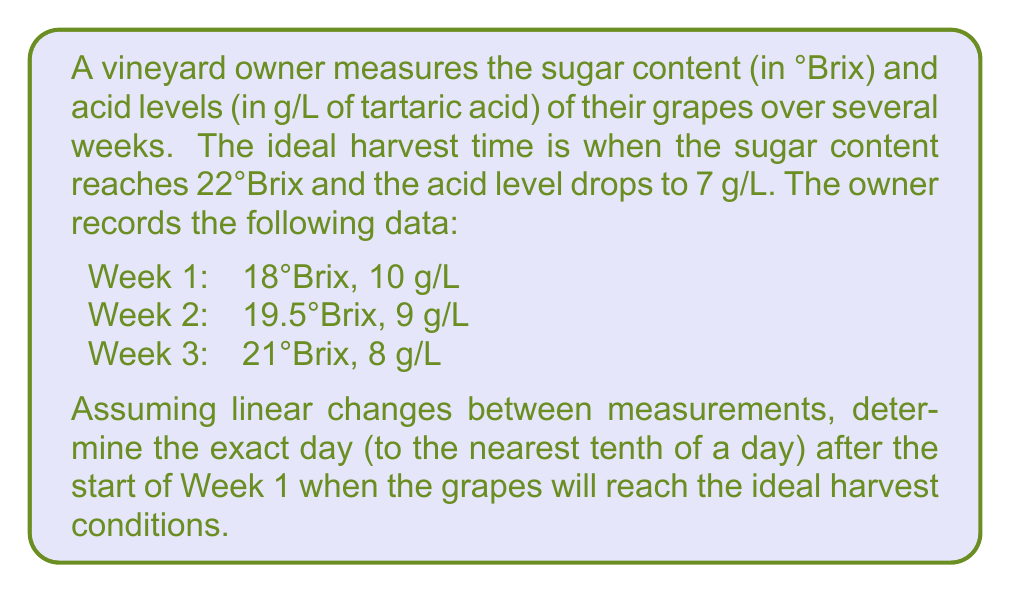Give your solution to this math problem. To solve this problem, we need to calculate the rates of change for both sugar content and acid levels, then determine when they will reach the ideal values.

1. Calculate the rate of change for sugar content:
   $$\text{Sugar rate} = \frac{21 - 18}{14 \text{ days}} = \frac{3}{14} = 0.2143 \text{ °Brix/day}$$

2. Calculate the rate of change for acid levels:
   $$\text{Acid rate} = \frac{8 - 10}{14 \text{ days}} = -\frac{1}{7} = -0.1429 \text{ g/L/day}$$

3. Calculate the time needed to reach 22°Brix from Week 3:
   $$t_{\text{sugar}} = \frac{22 - 21}{0.2143} = 4.67 \text{ days}$$

4. Calculate the time needed to reach 7 g/L acid from Week 3:
   $$t_{\text{acid}} = \frac{7 - 8}{-0.1429} = 7 \text{ days}$$

5. The ideal harvest time will be when both conditions are met, which is the later of the two times. In this case, it's 7 days after Week 3.

6. Calculate the total number of days from the start of Week 1:
   $$\text{Total days} = 14 \text{ (2 weeks)} + 7 = 21 \text{ days}$$

Therefore, the ideal harvest time will be 21 days after the start of Week 1.
Answer: 21.0 days 